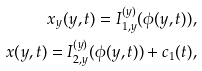<formula> <loc_0><loc_0><loc_500><loc_500>{ x _ { y } } ( y , t ) = I _ { 1 , y } ^ { ( y ) } ( \phi ( y , t ) ) , \\ x ( y , t ) = I _ { 2 , y } ^ { ( y ) } ( \phi ( y , t ) ) + { c _ { 1 } } ( t ) ,</formula> 